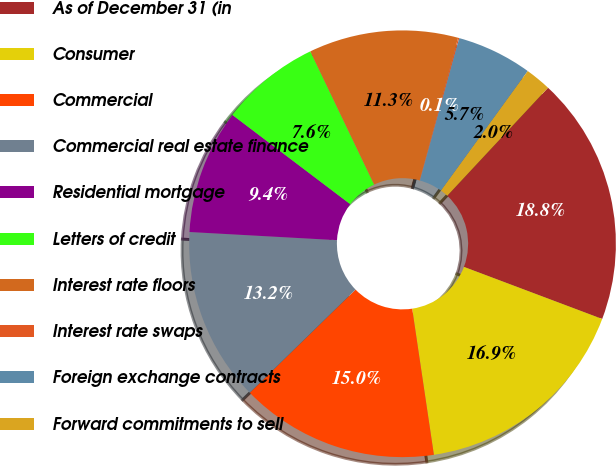Convert chart. <chart><loc_0><loc_0><loc_500><loc_500><pie_chart><fcel>As of December 31 (in<fcel>Consumer<fcel>Commercial<fcel>Commercial real estate finance<fcel>Residential mortgage<fcel>Letters of credit<fcel>Interest rate floors<fcel>Interest rate swaps<fcel>Foreign exchange contracts<fcel>Forward commitments to sell<nl><fcel>18.79%<fcel>16.92%<fcel>15.05%<fcel>13.18%<fcel>9.44%<fcel>7.57%<fcel>11.31%<fcel>0.09%<fcel>5.7%<fcel>1.96%<nl></chart> 